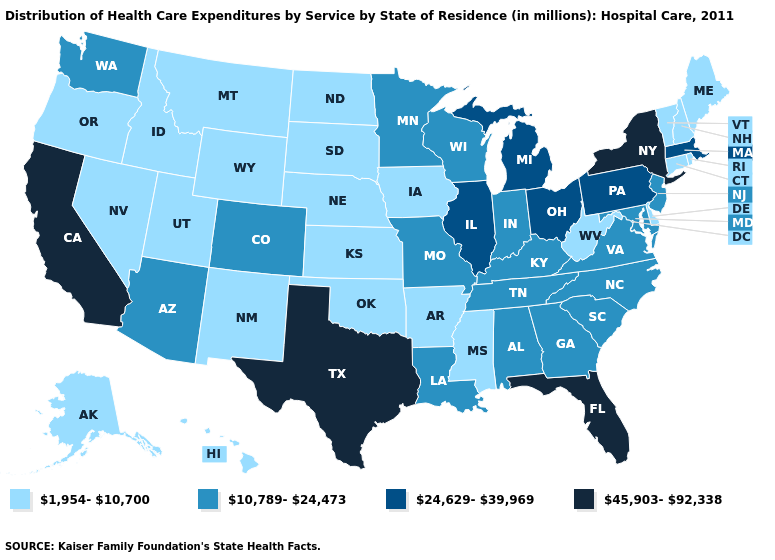What is the highest value in the Northeast ?
Keep it brief. 45,903-92,338. What is the highest value in states that border Iowa?
Give a very brief answer. 24,629-39,969. Does North Dakota have the same value as Illinois?
Answer briefly. No. Name the states that have a value in the range 45,903-92,338?
Quick response, please. California, Florida, New York, Texas. Name the states that have a value in the range 10,789-24,473?
Short answer required. Alabama, Arizona, Colorado, Georgia, Indiana, Kentucky, Louisiana, Maryland, Minnesota, Missouri, New Jersey, North Carolina, South Carolina, Tennessee, Virginia, Washington, Wisconsin. Does Missouri have a higher value than Wisconsin?
Quick response, please. No. Name the states that have a value in the range 24,629-39,969?
Concise answer only. Illinois, Massachusetts, Michigan, Ohio, Pennsylvania. Does Utah have the lowest value in the USA?
Quick response, please. Yes. What is the highest value in the West ?
Give a very brief answer. 45,903-92,338. Which states have the lowest value in the Northeast?
Concise answer only. Connecticut, Maine, New Hampshire, Rhode Island, Vermont. Name the states that have a value in the range 1,954-10,700?
Give a very brief answer. Alaska, Arkansas, Connecticut, Delaware, Hawaii, Idaho, Iowa, Kansas, Maine, Mississippi, Montana, Nebraska, Nevada, New Hampshire, New Mexico, North Dakota, Oklahoma, Oregon, Rhode Island, South Dakota, Utah, Vermont, West Virginia, Wyoming. Which states hav the highest value in the West?
Quick response, please. California. Name the states that have a value in the range 45,903-92,338?
Give a very brief answer. California, Florida, New York, Texas. Does the map have missing data?
Answer briefly. No. Among the states that border New Jersey , does New York have the highest value?
Quick response, please. Yes. 